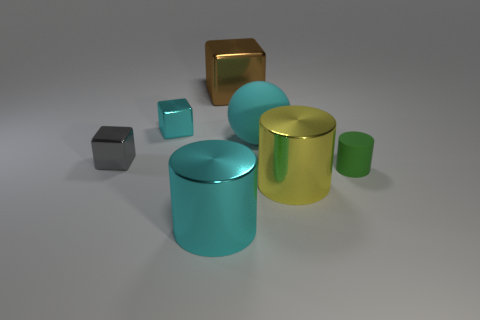Add 3 cyan rubber spheres. How many objects exist? 10 Subtract all spheres. How many objects are left? 6 Add 4 small cyan things. How many small cyan things are left? 5 Add 1 tiny purple matte things. How many tiny purple matte things exist? 1 Subtract 0 green balls. How many objects are left? 7 Subtract all big brown metallic objects. Subtract all small green objects. How many objects are left? 5 